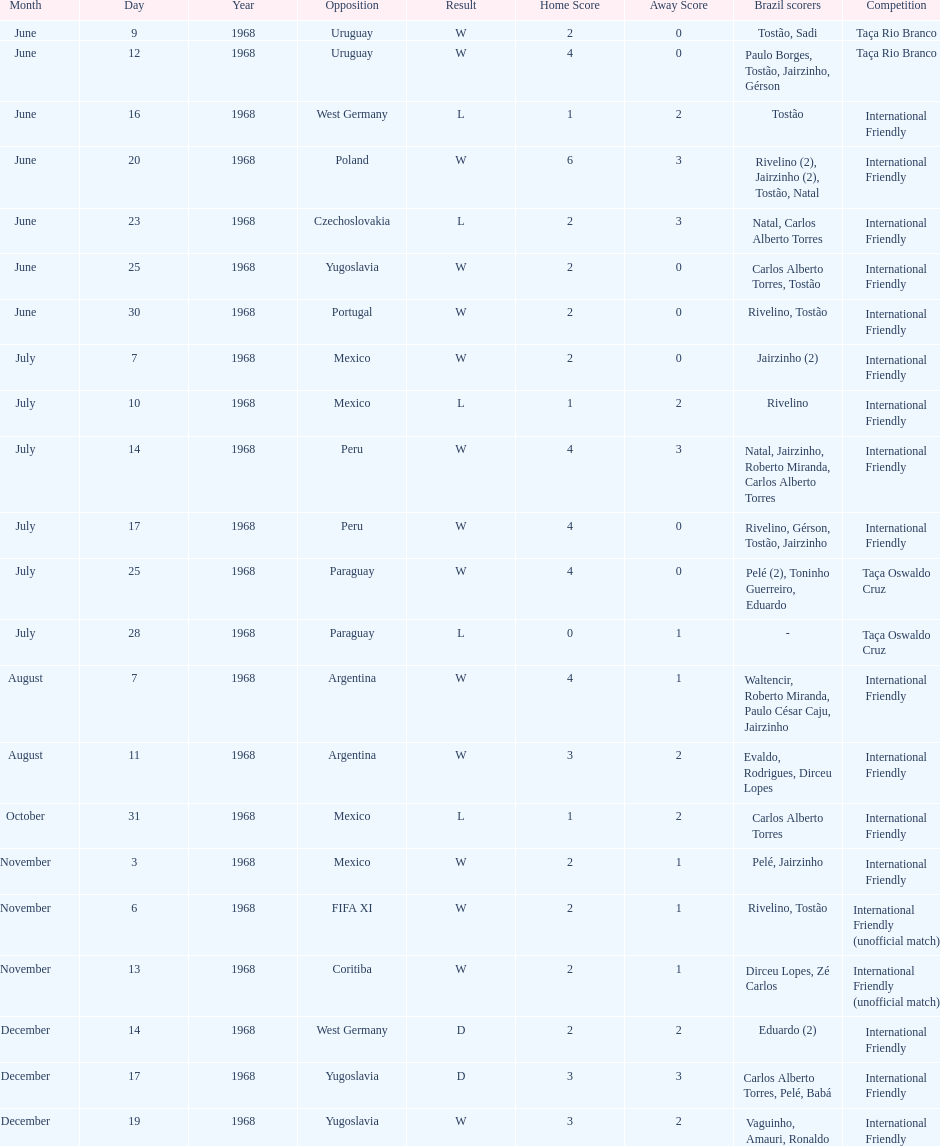How many matches are wins? 15. 